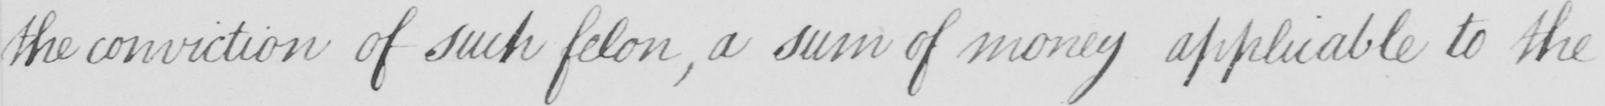Transcribe the text shown in this historical manuscript line. the conviction of such felon  , a sum of money applicable to the 